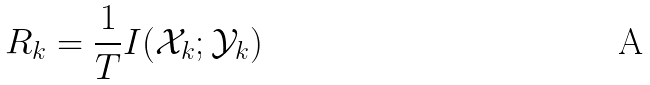<formula> <loc_0><loc_0><loc_500><loc_500>R _ { k } = \frac { 1 } { T } I ( \mathcal { X } _ { k } ; \mathcal { Y } _ { k } )</formula> 